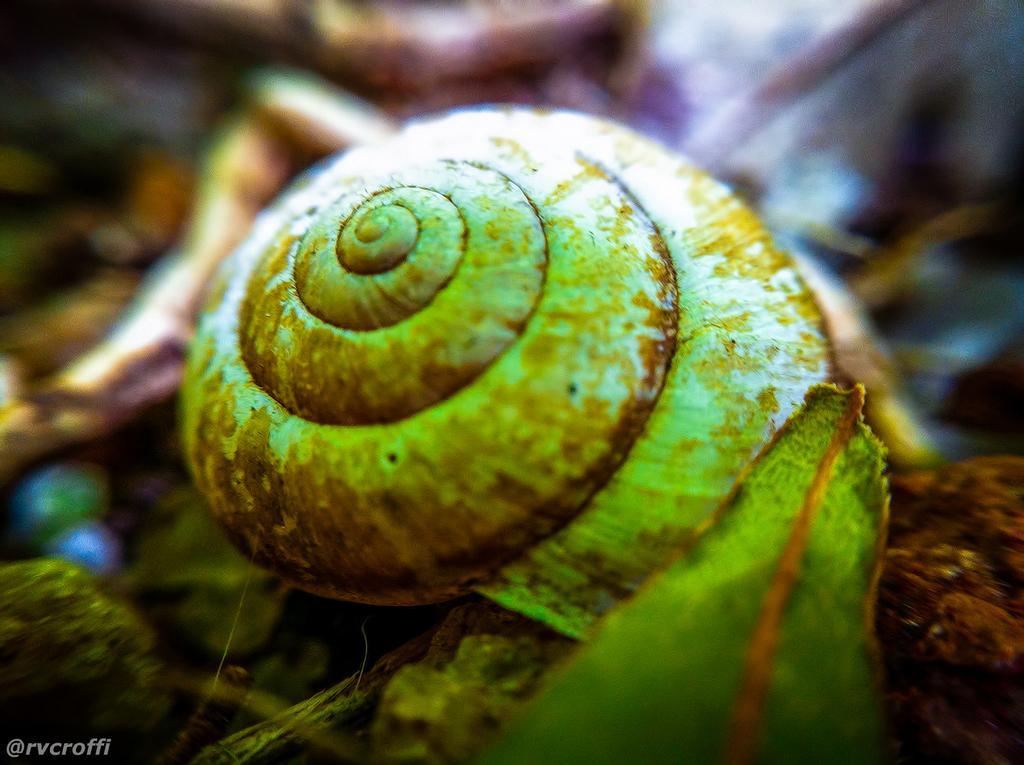How would you summarize this image in a sentence or two? In the picture I can see a snail and a leaf here and the surroundings of the image are blurred. Here I can see the watermark on the bottom left side of the image. 